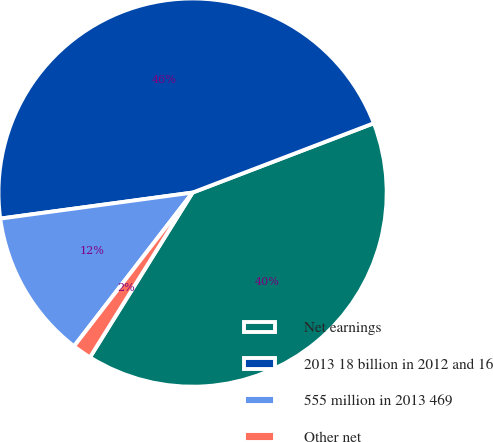Convert chart. <chart><loc_0><loc_0><loc_500><loc_500><pie_chart><fcel>Net earnings<fcel>2013 18 billion in 2012 and 16<fcel>555 million in 2013 469<fcel>Other net<nl><fcel>39.68%<fcel>46.32%<fcel>12.4%<fcel>1.59%<nl></chart> 